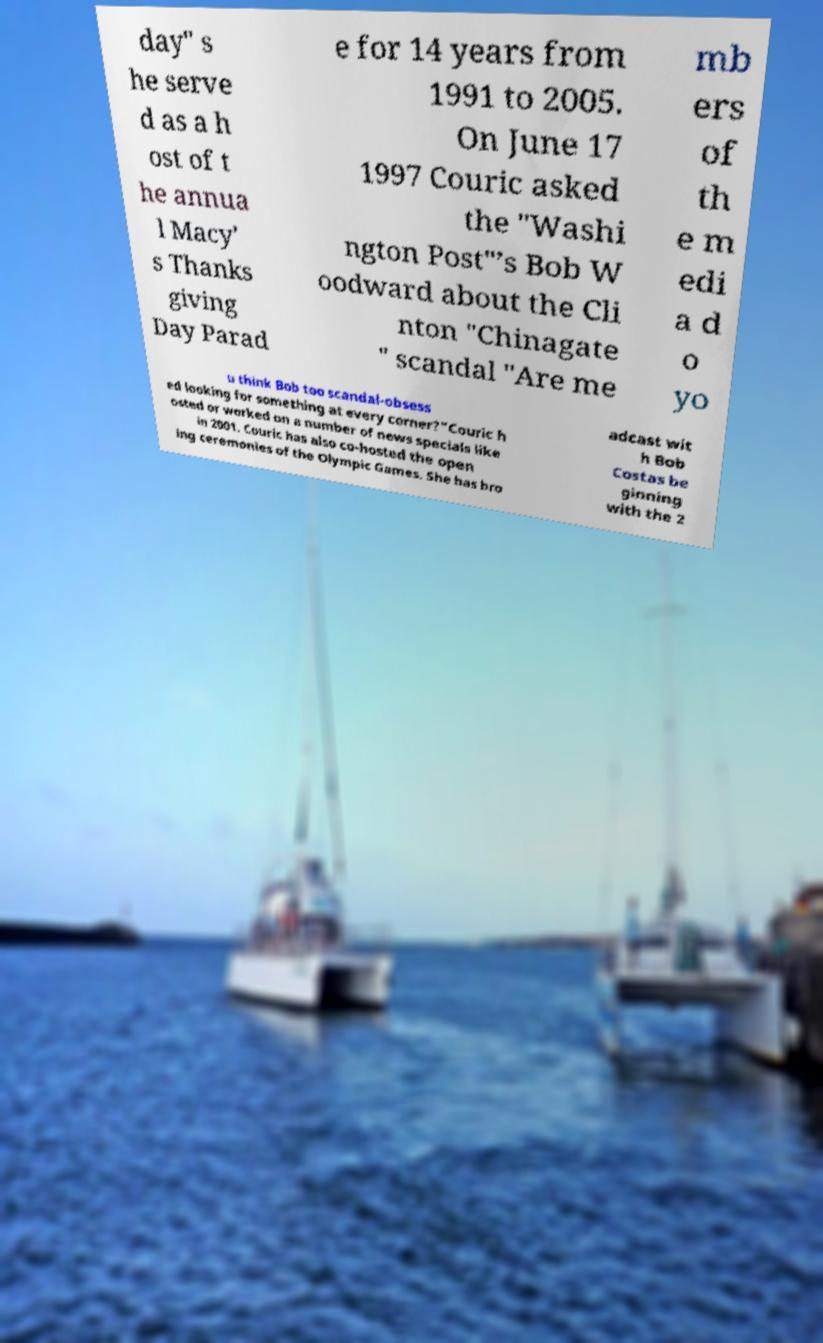There's text embedded in this image that I need extracted. Can you transcribe it verbatim? day" s he serve d as a h ost of t he annua l Macy' s Thanks giving Day Parad e for 14 years from 1991 to 2005. On June 17 1997 Couric asked the "Washi ngton Post"’s Bob W oodward about the Cli nton "Chinagate " scandal "Are me mb ers of th e m edi a d o yo u think Bob too scandal-obsess ed looking for something at every corner?"Couric h osted or worked on a number of news specials like in 2001. Couric has also co-hosted the open ing ceremonies of the Olympic Games. She has bro adcast wit h Bob Costas be ginning with the 2 